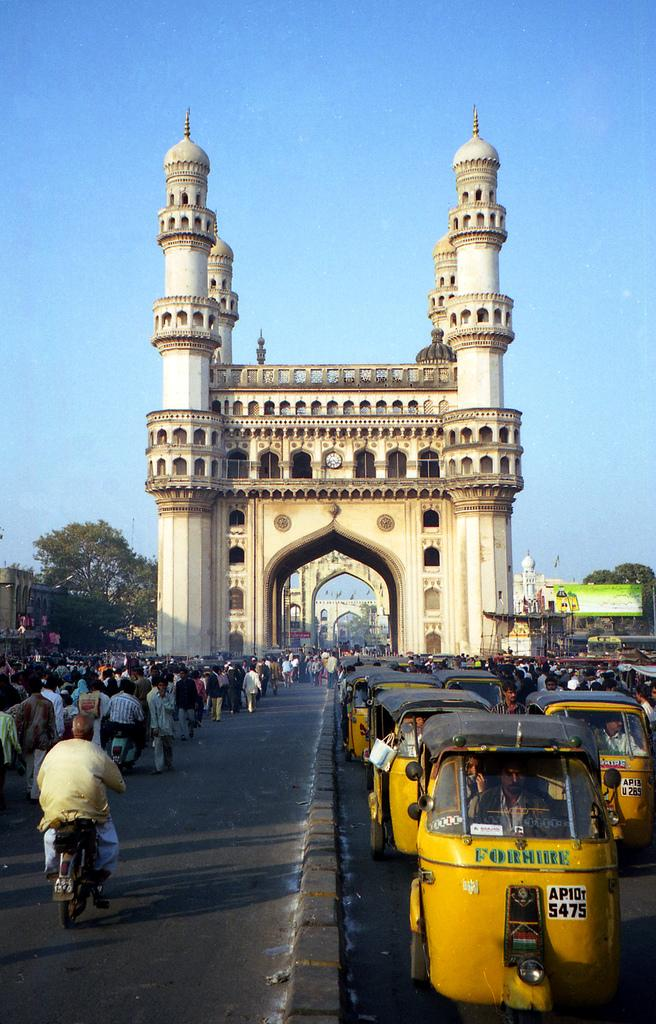<image>
Describe the image concisely. A line of yellow vehicles that say, ‘For Hire’, on the front are next to a crowded street and in front of a large ornate building. 